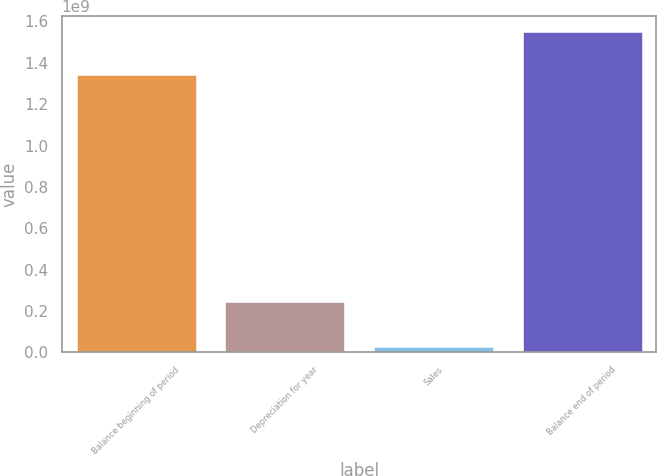Convert chart to OTSL. <chart><loc_0><loc_0><loc_500><loc_500><bar_chart><fcel>Balance beginning of period<fcel>Depreciation for year<fcel>Sales<fcel>Balance end of period<nl><fcel>1.34315e+09<fcel>2.44904e+08<fcel>2.36109e+07<fcel>1.54938e+09<nl></chart> 